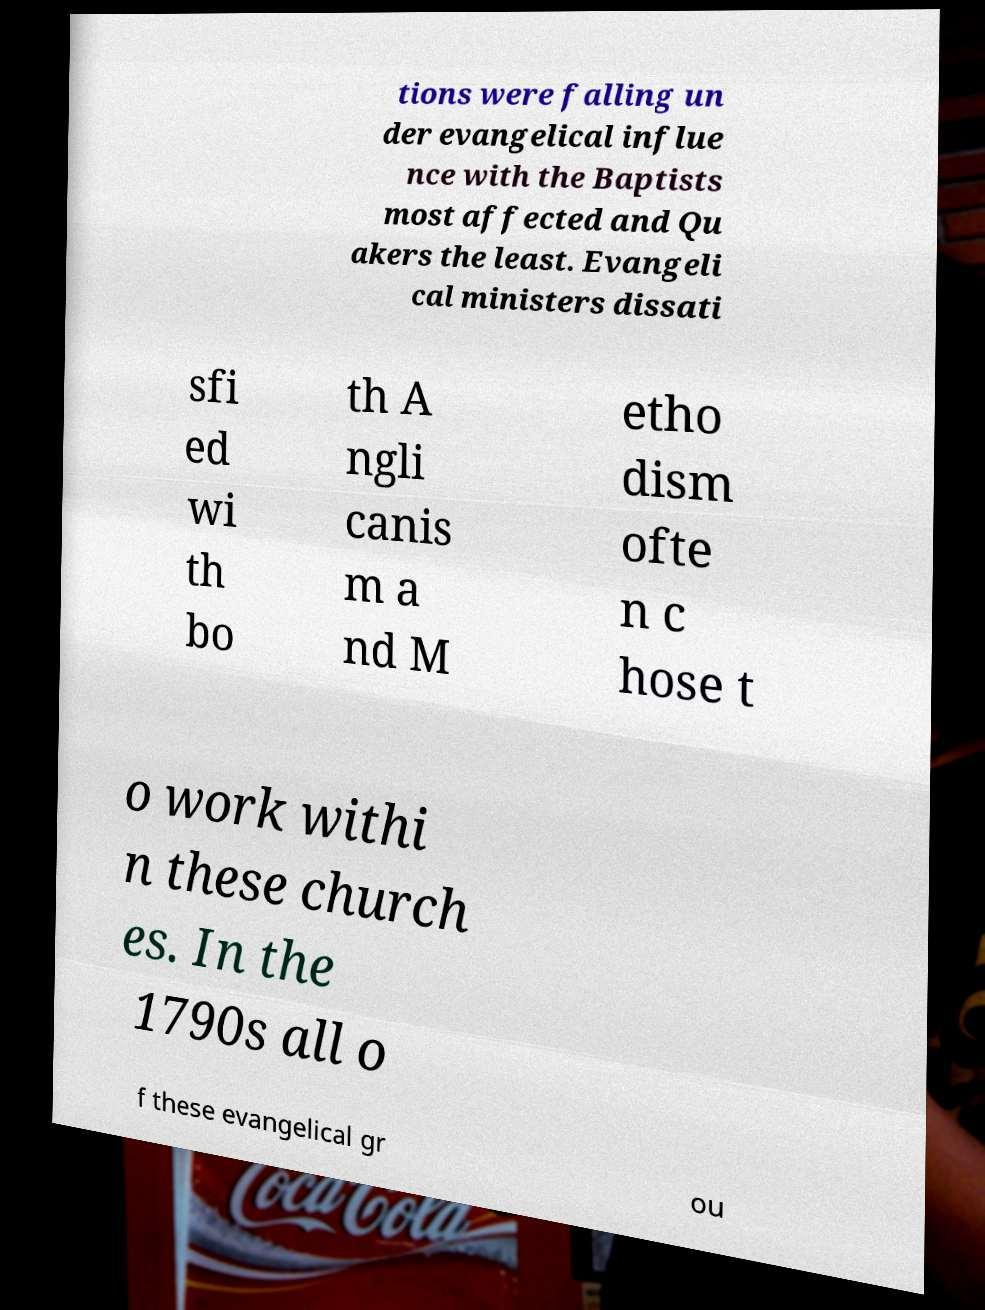Can you accurately transcribe the text from the provided image for me? tions were falling un der evangelical influe nce with the Baptists most affected and Qu akers the least. Evangeli cal ministers dissati sfi ed wi th bo th A ngli canis m a nd M etho dism ofte n c hose t o work withi n these church es. In the 1790s all o f these evangelical gr ou 